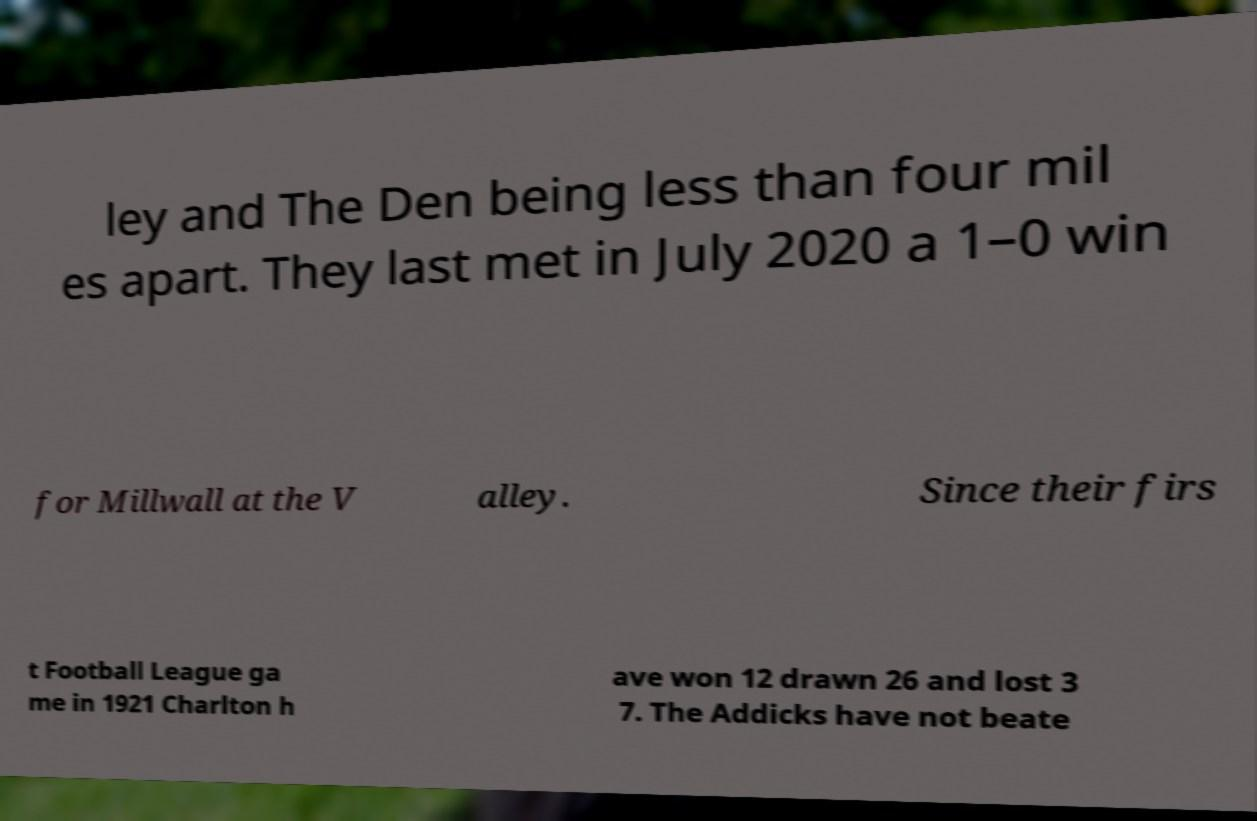Can you read and provide the text displayed in the image?This photo seems to have some interesting text. Can you extract and type it out for me? ley and The Den being less than four mil es apart. They last met in July 2020 a 1–0 win for Millwall at the V alley. Since their firs t Football League ga me in 1921 Charlton h ave won 12 drawn 26 and lost 3 7. The Addicks have not beate 